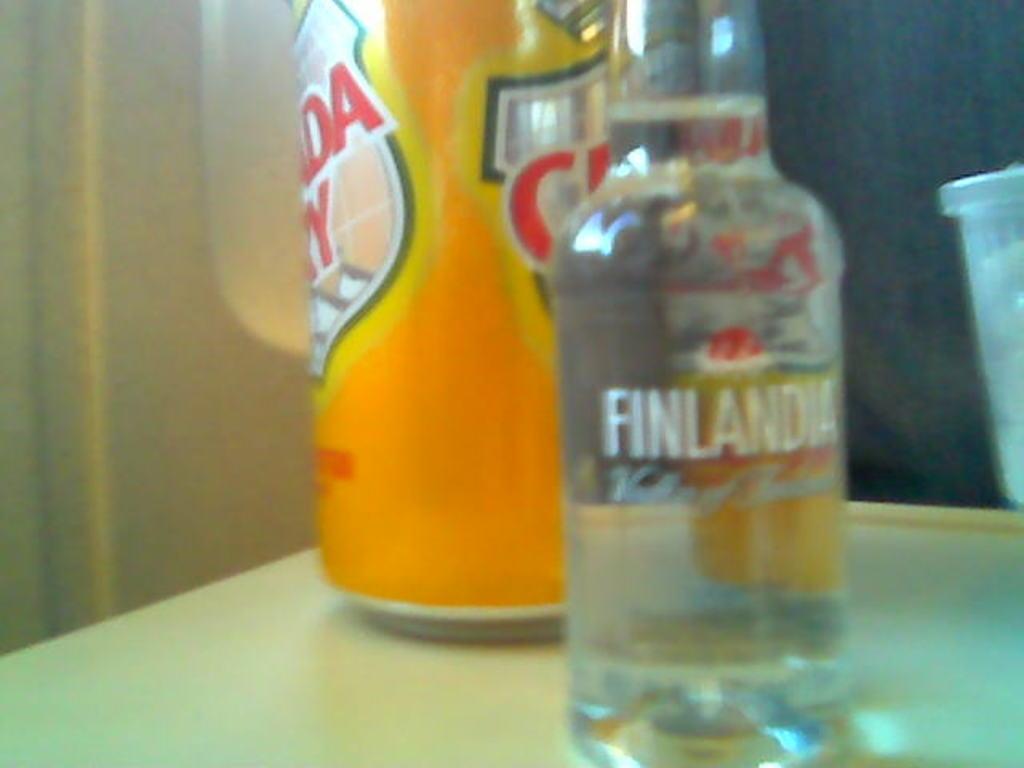What is the brand of vodka in the picture?
Your answer should be very brief. Finlandia. What brand is on the clear bottle?
Your answer should be compact. Finlandia. 